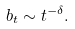Convert formula to latex. <formula><loc_0><loc_0><loc_500><loc_500>b _ { t } \sim t ^ { - \delta } .</formula> 